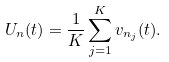Convert formula to latex. <formula><loc_0><loc_0><loc_500><loc_500>U _ { n } ( t ) = \frac { 1 } { K } \sum _ { j = 1 } ^ { K } v _ { n _ { j } } ( t ) .</formula> 